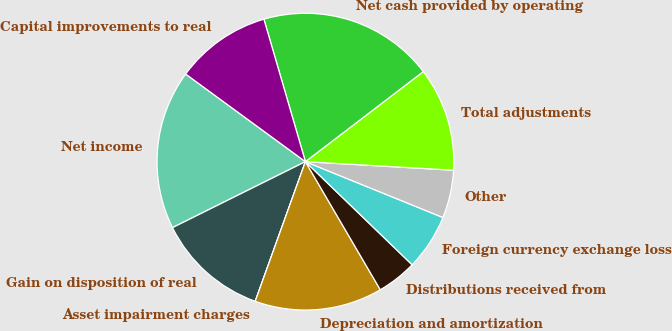Convert chart to OTSL. <chart><loc_0><loc_0><loc_500><loc_500><pie_chart><fcel>Net income<fcel>Gain on disposition of real<fcel>Asset impairment charges<fcel>Depreciation and amortization<fcel>Distributions received from<fcel>Foreign currency exchange loss<fcel>Other<fcel>Total adjustments<fcel>Net cash provided by operating<fcel>Capital improvements to real<nl><fcel>17.39%<fcel>12.17%<fcel>0.0%<fcel>13.91%<fcel>4.35%<fcel>6.09%<fcel>5.22%<fcel>11.3%<fcel>19.13%<fcel>10.43%<nl></chart> 